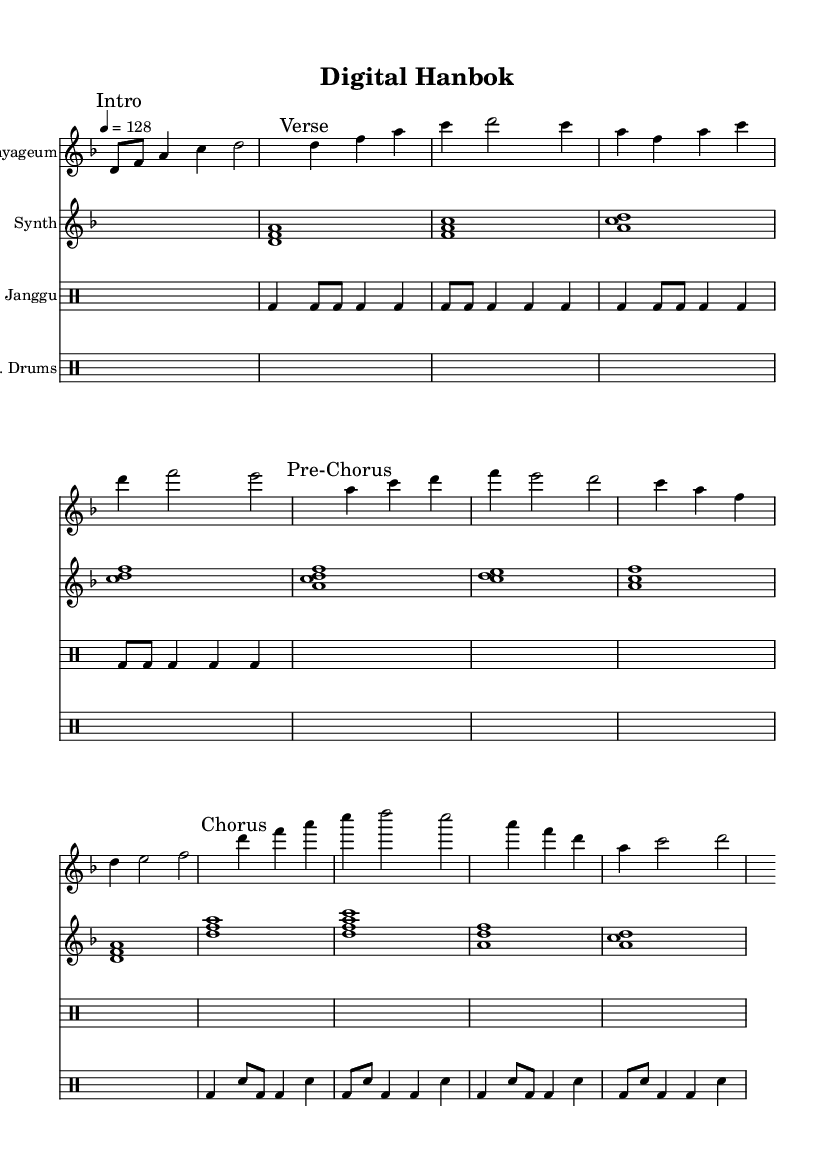what is the key signature of this music? The key signature is indicated at the beginning of the score where "d" occurs as the key signature for the piece. This means that it includes one flat (B flat) and is centered around the note D.
Answer: d minor what is the time signature of this music? The time signature is visible where "4/4" is noted at the beginning, indicating that there are four beats in a measure and the quarter note receives one beat.
Answer: 4/4 what is the tempo marking for this piece? The tempo marking appears at the start with "4 = 128," meaning that there are 128 beats per minute, and the quarter note is the unit of measurement.
Answer: 128 how many sections are defined in this music? The score is divided into sections that are clearly marked as "Intro," "Verse," "Pre-Chorus," and "Chorus." Counting these sections results in four distinct parts.
Answer: 4 which traditional instrument is used in this piece? Referring to the staff labeled "Gayageum," it becomes clear that this traditional Korean instrument is utilized within the piece as indicated in the instrumentation.
Answer: Gayageum what electronic element is merged with traditional instruments in this music? The presence of a staff labeled "Synth" indicates the use of synthesizers, combining modern electronic sounds with traditional elements.
Answer: Synthesizer how does the rhythm section incorporate both traditional and modern elements? The rhythm sections consist of two separate drum staffs: one labeled "Janggu," which represents a traditional Korean drum, and another labeled "E. Drums," indicating the use of contemporary electronic drums, showing a blend of styles.
Answer: Janggu and E. Drums 